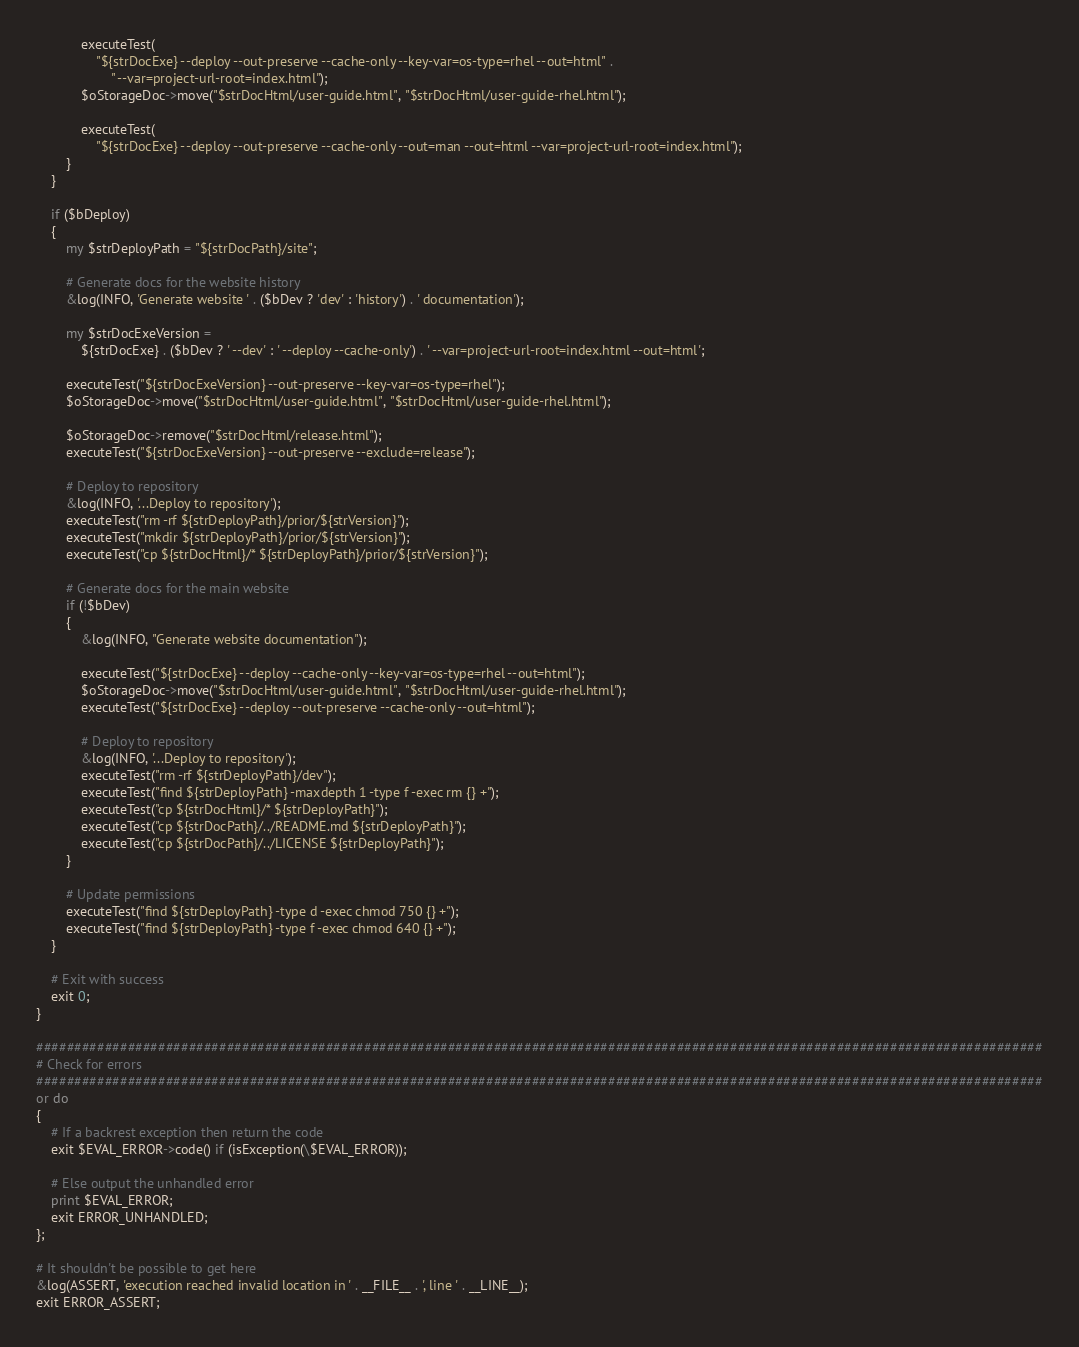Convert code to text. <code><loc_0><loc_0><loc_500><loc_500><_Perl_>
            executeTest(
                "${strDocExe} --deploy --out-preserve --cache-only --key-var=os-type=rhel --out=html" .
                    " --var=project-url-root=index.html");
            $oStorageDoc->move("$strDocHtml/user-guide.html", "$strDocHtml/user-guide-rhel.html");

            executeTest(
                "${strDocExe} --deploy --out-preserve --cache-only --out=man --out=html --var=project-url-root=index.html");
        }
    }

    if ($bDeploy)
    {
        my $strDeployPath = "${strDocPath}/site";

        # Generate docs for the website history
        &log(INFO, 'Generate website ' . ($bDev ? 'dev' : 'history') . ' documentation');

        my $strDocExeVersion =
            ${strDocExe} . ($bDev ? ' --dev' : ' --deploy --cache-only') . ' --var=project-url-root=index.html --out=html';

        executeTest("${strDocExeVersion} --out-preserve --key-var=os-type=rhel");
        $oStorageDoc->move("$strDocHtml/user-guide.html", "$strDocHtml/user-guide-rhel.html");

        $oStorageDoc->remove("$strDocHtml/release.html");
        executeTest("${strDocExeVersion} --out-preserve --exclude=release");

        # Deploy to repository
        &log(INFO, '...Deploy to repository');
        executeTest("rm -rf ${strDeployPath}/prior/${strVersion}");
        executeTest("mkdir ${strDeployPath}/prior/${strVersion}");
        executeTest("cp ${strDocHtml}/* ${strDeployPath}/prior/${strVersion}");

        # Generate docs for the main website
        if (!$bDev)
        {
            &log(INFO, "Generate website documentation");

            executeTest("${strDocExe} --deploy --cache-only --key-var=os-type=rhel --out=html");
            $oStorageDoc->move("$strDocHtml/user-guide.html", "$strDocHtml/user-guide-rhel.html");
            executeTest("${strDocExe} --deploy --out-preserve --cache-only --out=html");

            # Deploy to repository
            &log(INFO, '...Deploy to repository');
            executeTest("rm -rf ${strDeployPath}/dev");
            executeTest("find ${strDeployPath} -maxdepth 1 -type f -exec rm {} +");
            executeTest("cp ${strDocHtml}/* ${strDeployPath}");
            executeTest("cp ${strDocPath}/../README.md ${strDeployPath}");
            executeTest("cp ${strDocPath}/../LICENSE ${strDeployPath}");
        }

        # Update permissions
        executeTest("find ${strDeployPath} -type d -exec chmod 750 {} +");
        executeTest("find ${strDeployPath} -type f -exec chmod 640 {} +");
    }

    # Exit with success
    exit 0;
}

####################################################################################################################################
# Check for errors
####################################################################################################################################
or do
{
    # If a backrest exception then return the code
    exit $EVAL_ERROR->code() if (isException(\$EVAL_ERROR));

    # Else output the unhandled error
    print $EVAL_ERROR;
    exit ERROR_UNHANDLED;
};

# It shouldn't be possible to get here
&log(ASSERT, 'execution reached invalid location in ' . __FILE__ . ', line ' . __LINE__);
exit ERROR_ASSERT;
</code> 